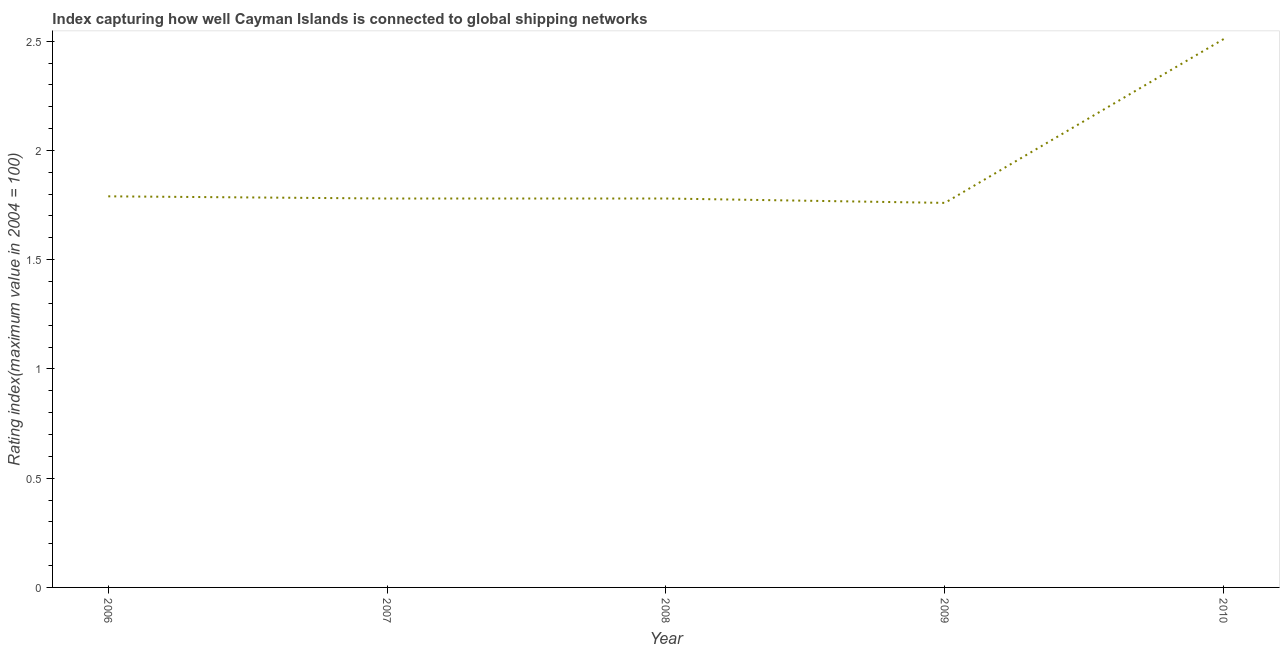What is the liner shipping connectivity index in 2010?
Your response must be concise. 2.51. Across all years, what is the maximum liner shipping connectivity index?
Your answer should be compact. 2.51. Across all years, what is the minimum liner shipping connectivity index?
Offer a terse response. 1.76. In which year was the liner shipping connectivity index maximum?
Your answer should be very brief. 2010. What is the sum of the liner shipping connectivity index?
Your answer should be compact. 9.62. What is the difference between the liner shipping connectivity index in 2006 and 2009?
Your response must be concise. 0.03. What is the average liner shipping connectivity index per year?
Keep it short and to the point. 1.92. What is the median liner shipping connectivity index?
Give a very brief answer. 1.78. What is the ratio of the liner shipping connectivity index in 2009 to that in 2010?
Provide a short and direct response. 0.7. What is the difference between the highest and the second highest liner shipping connectivity index?
Offer a very short reply. 0.72. What is the difference between the highest and the lowest liner shipping connectivity index?
Ensure brevity in your answer.  0.75. In how many years, is the liner shipping connectivity index greater than the average liner shipping connectivity index taken over all years?
Offer a terse response. 1. Does the liner shipping connectivity index monotonically increase over the years?
Keep it short and to the point. No. Does the graph contain any zero values?
Your response must be concise. No. What is the title of the graph?
Make the answer very short. Index capturing how well Cayman Islands is connected to global shipping networks. What is the label or title of the Y-axis?
Make the answer very short. Rating index(maximum value in 2004 = 100). What is the Rating index(maximum value in 2004 = 100) in 2006?
Your answer should be compact. 1.79. What is the Rating index(maximum value in 2004 = 100) in 2007?
Make the answer very short. 1.78. What is the Rating index(maximum value in 2004 = 100) in 2008?
Ensure brevity in your answer.  1.78. What is the Rating index(maximum value in 2004 = 100) in 2009?
Offer a very short reply. 1.76. What is the Rating index(maximum value in 2004 = 100) in 2010?
Provide a short and direct response. 2.51. What is the difference between the Rating index(maximum value in 2004 = 100) in 2006 and 2007?
Make the answer very short. 0.01. What is the difference between the Rating index(maximum value in 2004 = 100) in 2006 and 2009?
Provide a succinct answer. 0.03. What is the difference between the Rating index(maximum value in 2004 = 100) in 2006 and 2010?
Provide a succinct answer. -0.72. What is the difference between the Rating index(maximum value in 2004 = 100) in 2007 and 2009?
Give a very brief answer. 0.02. What is the difference between the Rating index(maximum value in 2004 = 100) in 2007 and 2010?
Your answer should be very brief. -0.73. What is the difference between the Rating index(maximum value in 2004 = 100) in 2008 and 2009?
Provide a short and direct response. 0.02. What is the difference between the Rating index(maximum value in 2004 = 100) in 2008 and 2010?
Offer a terse response. -0.73. What is the difference between the Rating index(maximum value in 2004 = 100) in 2009 and 2010?
Ensure brevity in your answer.  -0.75. What is the ratio of the Rating index(maximum value in 2004 = 100) in 2006 to that in 2010?
Provide a short and direct response. 0.71. What is the ratio of the Rating index(maximum value in 2004 = 100) in 2007 to that in 2010?
Offer a terse response. 0.71. What is the ratio of the Rating index(maximum value in 2004 = 100) in 2008 to that in 2010?
Provide a short and direct response. 0.71. What is the ratio of the Rating index(maximum value in 2004 = 100) in 2009 to that in 2010?
Keep it short and to the point. 0.7. 